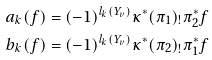Convert formula to latex. <formula><loc_0><loc_0><loc_500><loc_500>a _ { k } ( f ) & = ( - 1 ) ^ { l _ { k } ( Y _ { v } ) } \kappa ^ { * } ( \pi _ { 1 } ) _ { ! } \pi _ { 2 } ^ { * } f \\ b _ { k } ( f ) & = ( - 1 ) ^ { l _ { k } ( Y _ { v } ) } \kappa ^ { * } ( \pi _ { 2 } ) _ { ! } \pi _ { 1 } ^ { * } f</formula> 